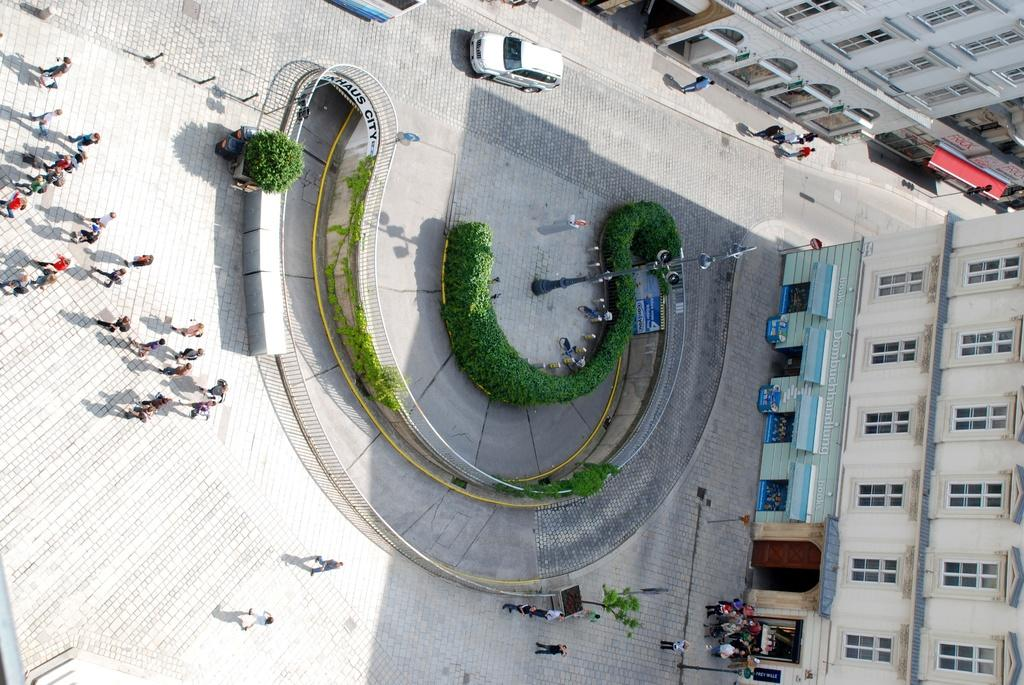What type of structures can be seen in the image? There are buildings in the image. What architectural features are visible on the buildings? There are windows and poles visible on the buildings. What else can be seen in the image besides buildings? There are boards, people, a vehicle, trees, railing, and additional objects in the image. What type of glass can be seen in the image? There is no glass present in the image. What type of beam is holding up the building in the image? There is no beam visible in the image, and the specific construction methods of the buildings are not discernible. 